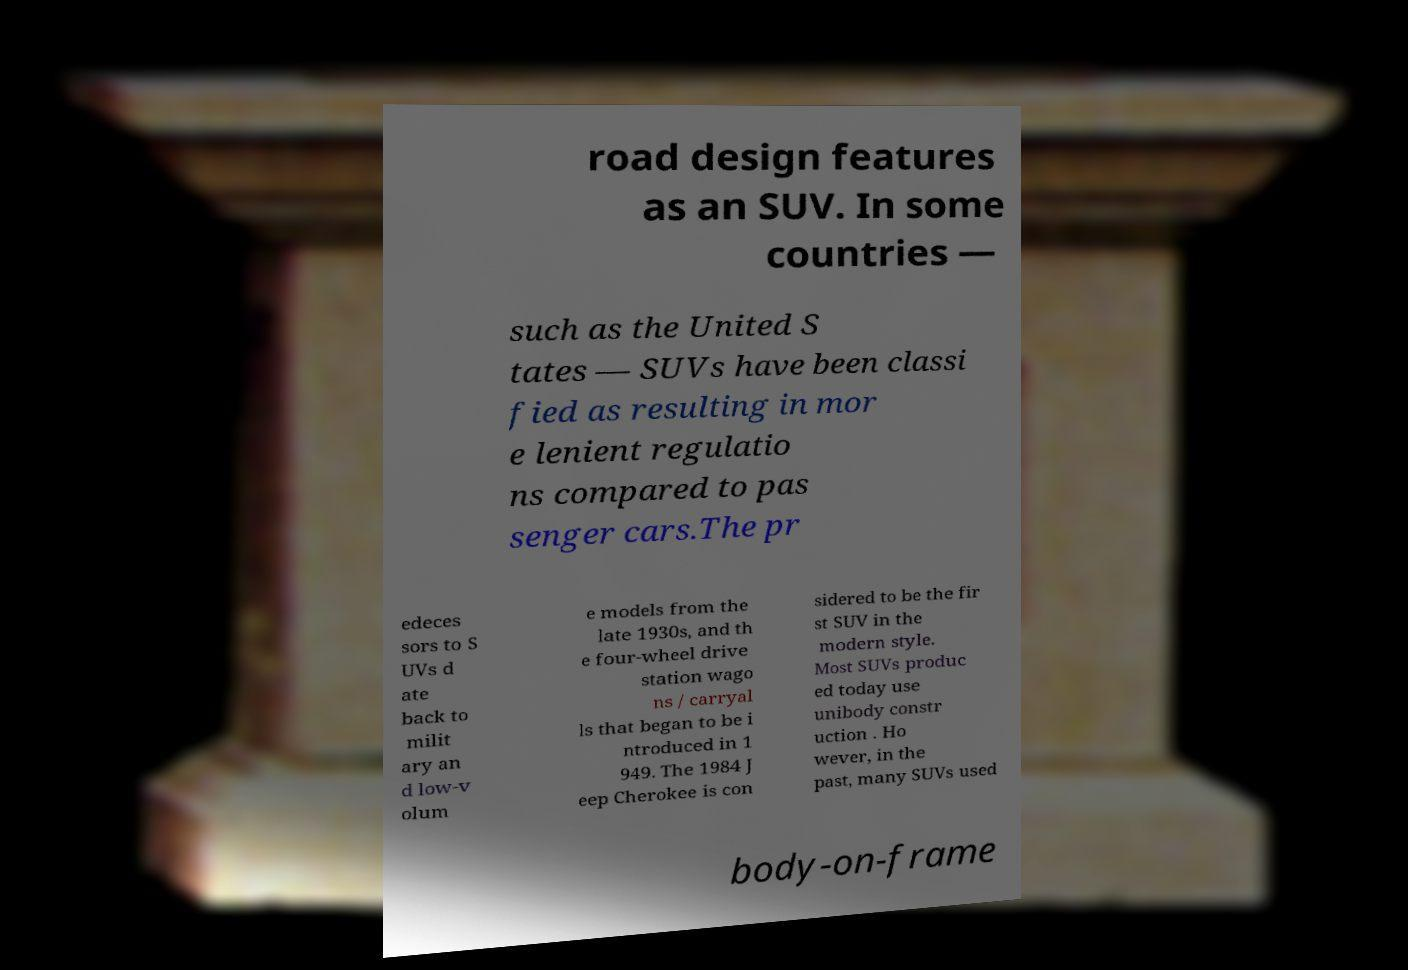Could you extract and type out the text from this image? road design features as an SUV. In some countries — such as the United S tates — SUVs have been classi fied as resulting in mor e lenient regulatio ns compared to pas senger cars.The pr edeces sors to S UVs d ate back to milit ary an d low-v olum e models from the late 1930s, and th e four-wheel drive station wago ns / carryal ls that began to be i ntroduced in 1 949. The 1984 J eep Cherokee is con sidered to be the fir st SUV in the modern style. Most SUVs produc ed today use unibody constr uction . Ho wever, in the past, many SUVs used body-on-frame 